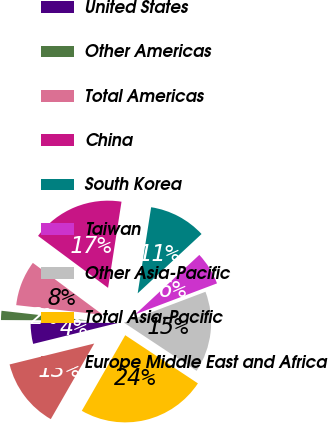Convert chart to OTSL. <chart><loc_0><loc_0><loc_500><loc_500><pie_chart><fcel>United States<fcel>Other Americas<fcel>Total Americas<fcel>China<fcel>South Korea<fcel>Taiwan<fcel>Other Asia-Pacific<fcel>Total Asia-Pacific<fcel>Europe Middle East and Africa<nl><fcel>3.93%<fcel>1.7%<fcel>8.39%<fcel>17.31%<fcel>10.62%<fcel>6.16%<fcel>15.08%<fcel>23.99%<fcel>12.85%<nl></chart> 